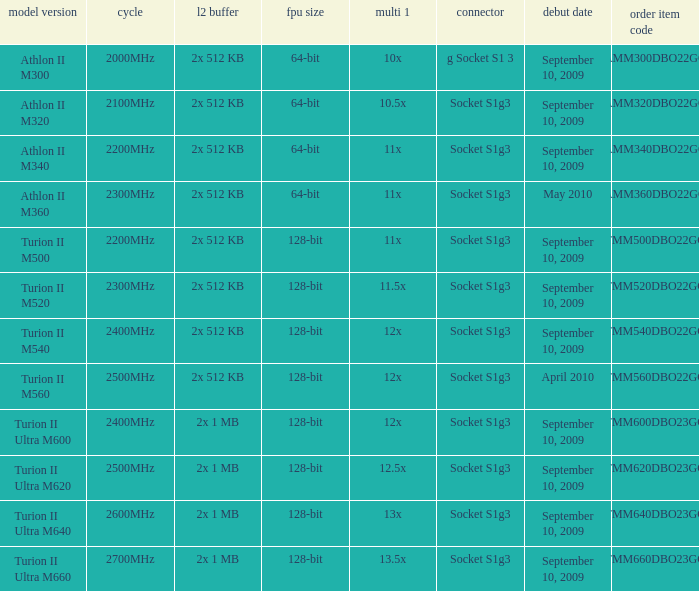What is the order part number with a 12.5x multi 1? TMM620DBO23GQ. 